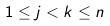Convert formula to latex. <formula><loc_0><loc_0><loc_500><loc_500>1 \leq j < k \leq n</formula> 